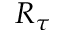<formula> <loc_0><loc_0><loc_500><loc_500>R _ { \tau }</formula> 